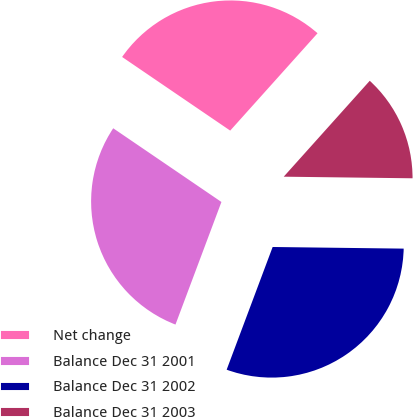Convert chart. <chart><loc_0><loc_0><loc_500><loc_500><pie_chart><fcel>Net change<fcel>Balance Dec 31 2001<fcel>Balance Dec 31 2002<fcel>Balance Dec 31 2003<nl><fcel>27.12%<fcel>28.81%<fcel>30.51%<fcel>13.56%<nl></chart> 